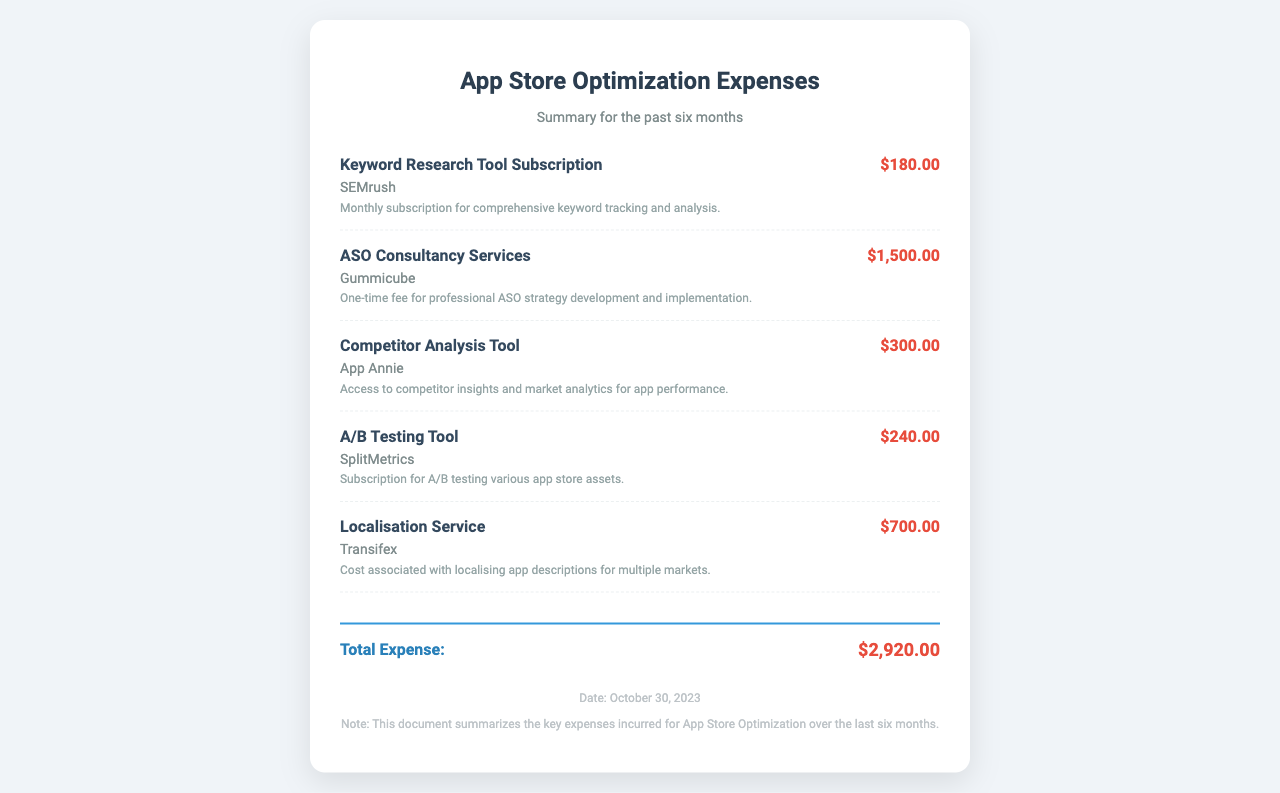What is the total amount of expenses? The total amount of expenses is listed at the bottom of the document.
Answer: $2,920.00 Who provided the Keyword Research Tool Subscription? The provider of the Keyword Research Tool Subscription is mentioned in the document.
Answer: SEMrush How much did the ASO Consultancy Services cost? The cost for ASO Consultancy Services is specifically stated in the document.
Answer: $1,500.00 What service is associated with Transifex? The service associated with Transifex is described in the expense details.
Answer: Localisation Service What is the date of this receipt? The date is provided in the footer section of the document.
Answer: October 30, 2023 How many different expenses are listed in the document? The number of different expenses is determined by counting the individual expense items present.
Answer: 5 Which tool is used for A/B testing? The document specifies the tool used for A/B testing.
Answer: SplitMetrics What is the purpose of the Competitor Analysis Tool? The purpose is described in the corresponding expense item.
Answer: Market analytics for app performance What kind of service does Gummicube provide? The document outlines the type of service provided by Gummicube.
Answer: ASO Consultancy Services 